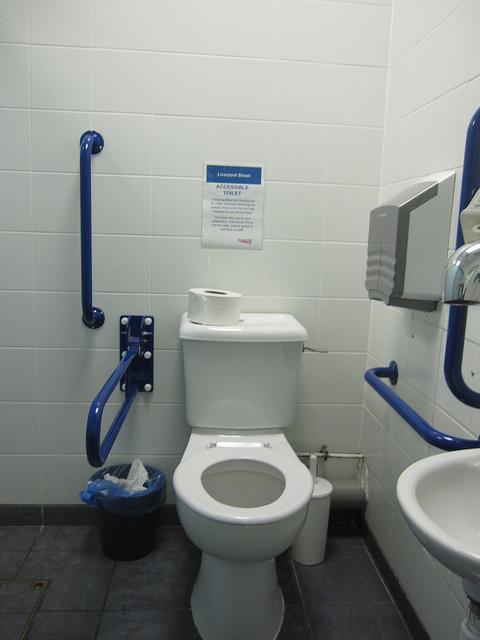What is on the back of the toilet?
Quick response, please. Toilet paper. What color are the bars?
Short answer required. Blue. Is the photographer visible?
Be succinct. No. How many trash cans are present?
Answer briefly. 1. 